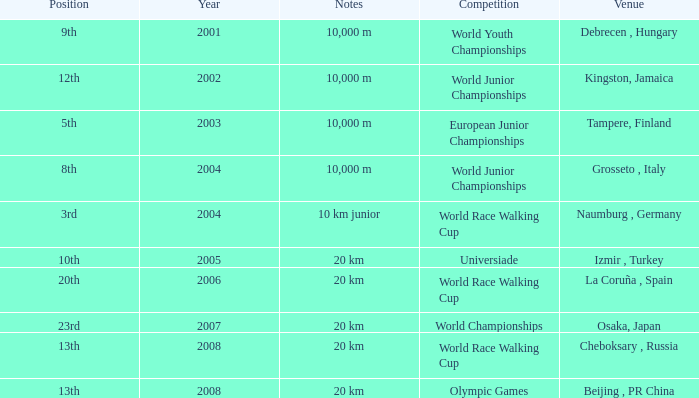I'm looking to parse the entire table for insights. Could you assist me with that? {'header': ['Position', 'Year', 'Notes', 'Competition', 'Venue'], 'rows': [['9th', '2001', '10,000 m', 'World Youth Championships', 'Debrecen , Hungary'], ['12th', '2002', '10,000 m', 'World Junior Championships', 'Kingston, Jamaica'], ['5th', '2003', '10,000 m', 'European Junior Championships', 'Tampere, Finland'], ['8th', '2004', '10,000 m', 'World Junior Championships', 'Grosseto , Italy'], ['3rd', '2004', '10 km junior', 'World Race Walking Cup', 'Naumburg , Germany'], ['10th', '2005', '20 km', 'Universiade', 'Izmir , Turkey'], ['20th', '2006', '20 km', 'World Race Walking Cup', 'La Coruña , Spain'], ['23rd', '2007', '20 km', 'World Championships', 'Osaka, Japan'], ['13th', '2008', '20 km', 'World Race Walking Cup', 'Cheboksary , Russia'], ['13th', '2008', '20 km', 'Olympic Games', 'Beijing , PR China']]} In which year did he compete in the Universiade? 2005.0. 